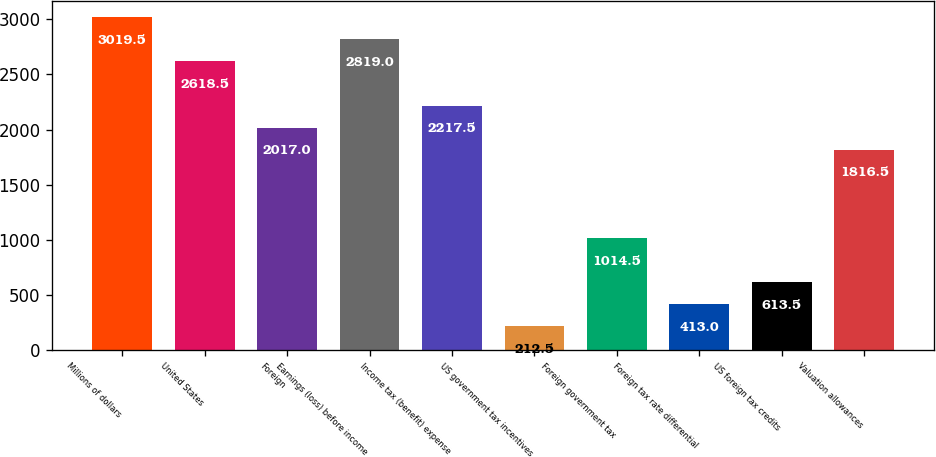Convert chart. <chart><loc_0><loc_0><loc_500><loc_500><bar_chart><fcel>Millions of dollars<fcel>United States<fcel>Foreign<fcel>Earnings (loss) before income<fcel>Income tax (benefit) expense<fcel>US government tax incentives<fcel>Foreign government tax<fcel>Foreign tax rate differential<fcel>US foreign tax credits<fcel>Valuation allowances<nl><fcel>3019.5<fcel>2618.5<fcel>2017<fcel>2819<fcel>2217.5<fcel>212.5<fcel>1014.5<fcel>413<fcel>613.5<fcel>1816.5<nl></chart> 